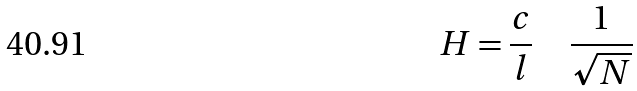<formula> <loc_0><loc_0><loc_500><loc_500>H = \frac { c } { l } \quad \frac { 1 } { \sqrt { N } }</formula> 